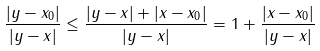Convert formula to latex. <formula><loc_0><loc_0><loc_500><loc_500>\frac { | y - x _ { 0 } | } { | y - x | } \leq \frac { | y - x | + | x - x _ { 0 } | } { | y - x | } = 1 + \frac { | x - x _ { 0 } | } { | y - x | }</formula> 